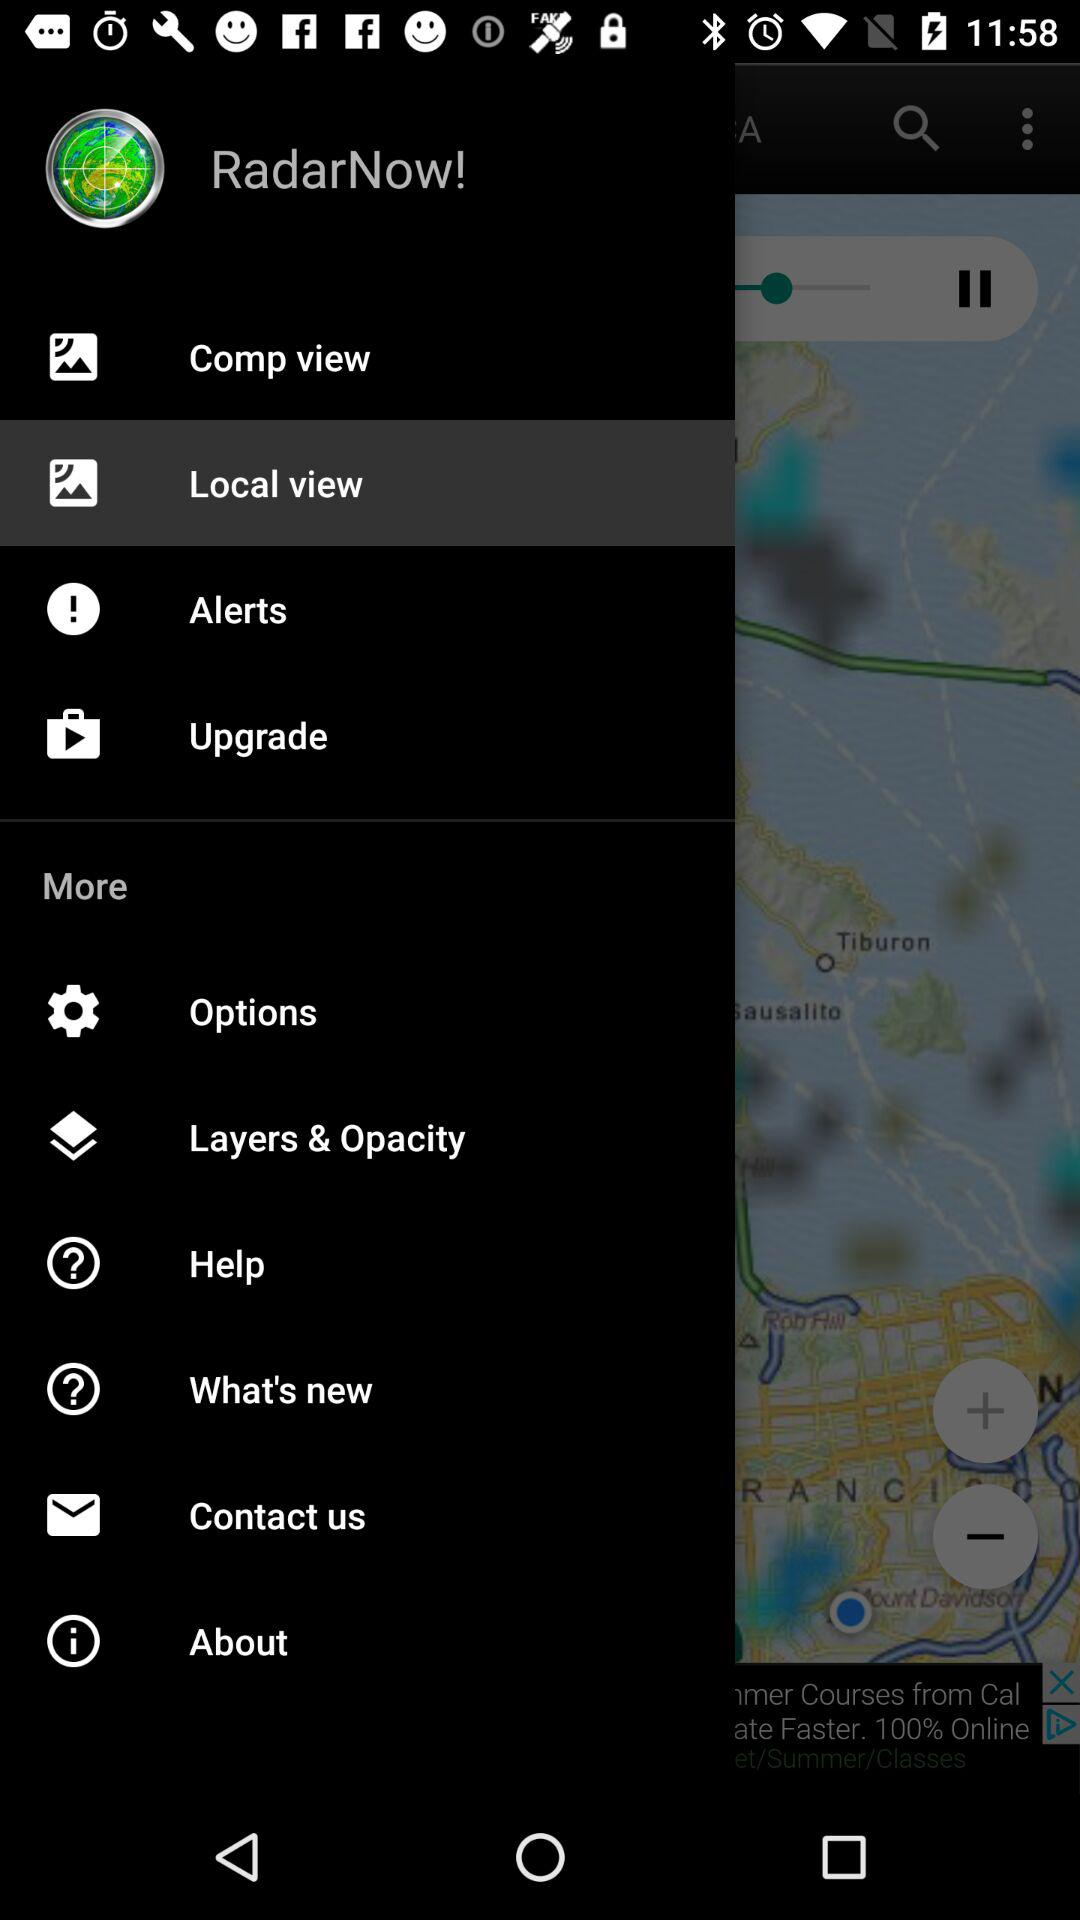What is the name of the application? The name of the application is "RadarNow!". 